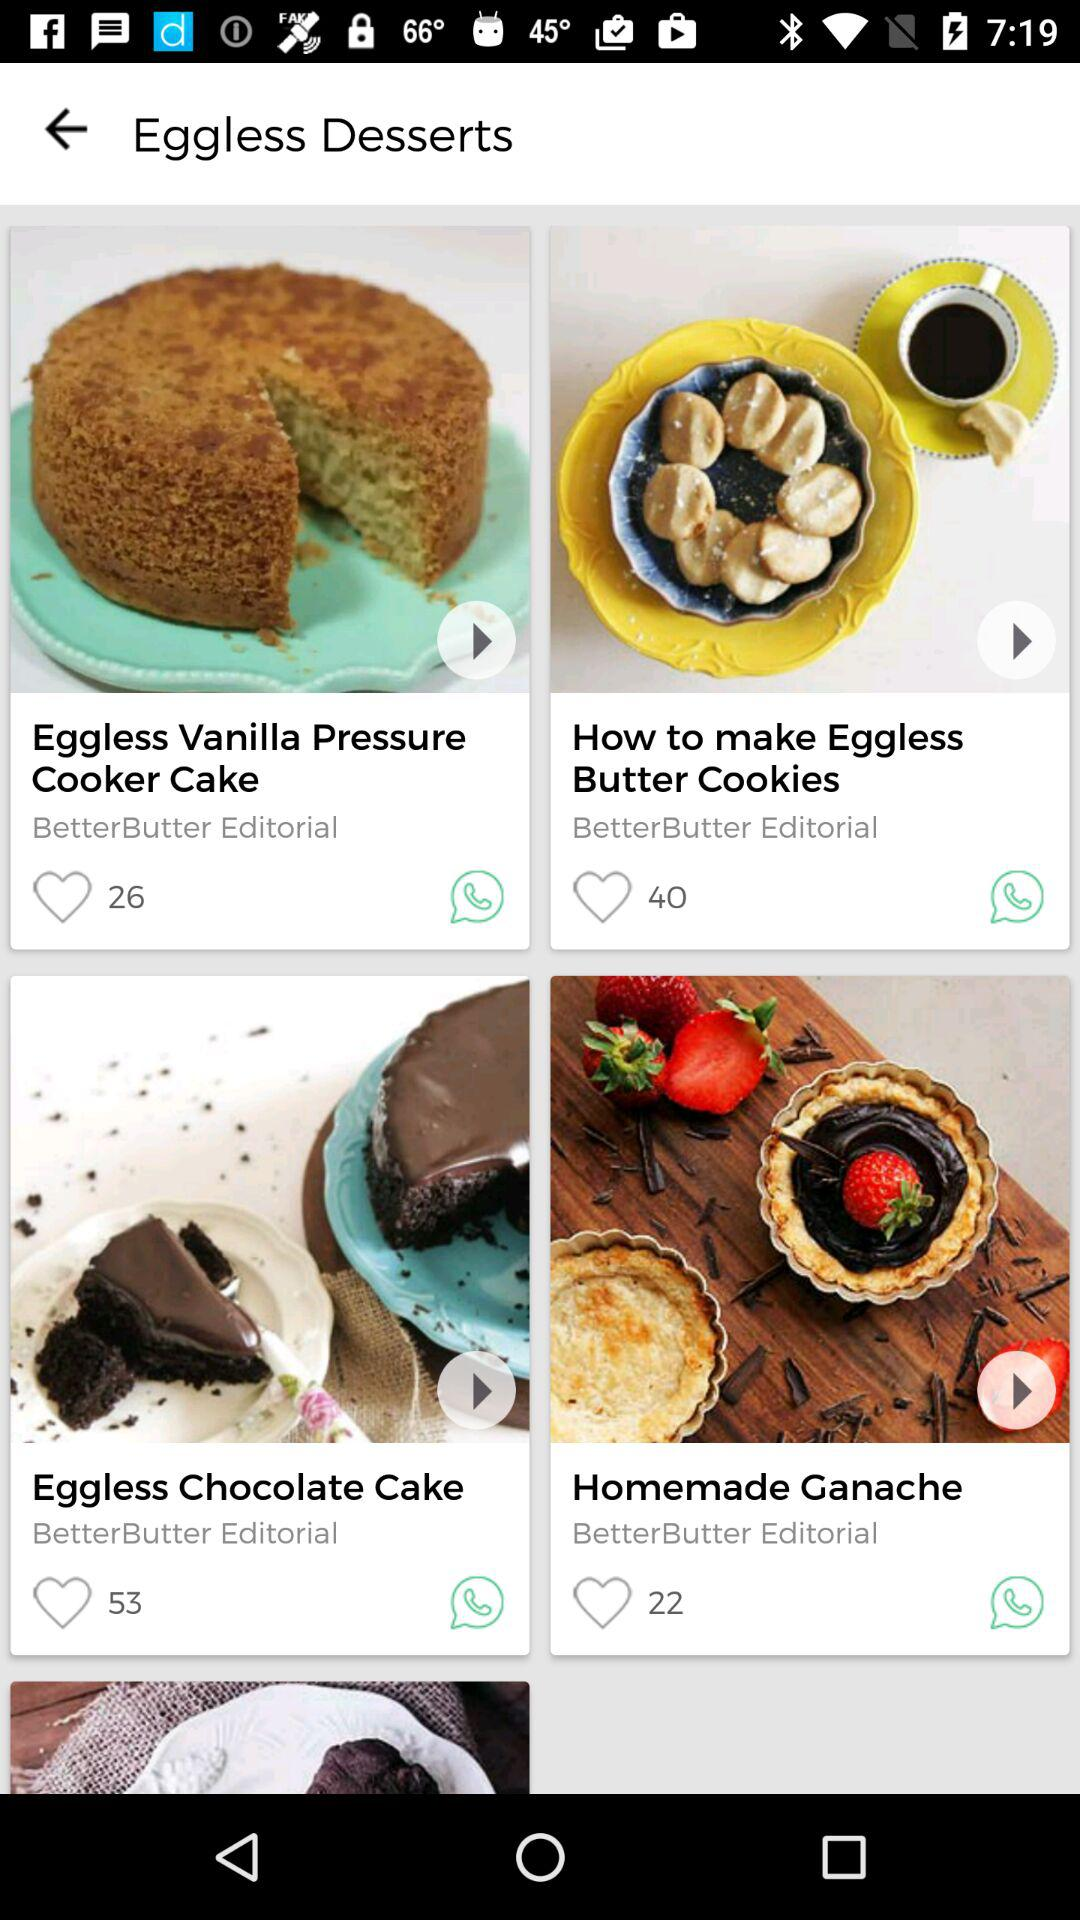What are the different eggless desserts available? The different eggless desserts available are "Vanilla Pressure Cooker Cake", "Butter Cookies", "Chocolate Cake" and "Homemade Ganache". 